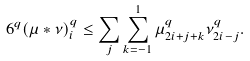Convert formula to latex. <formula><loc_0><loc_0><loc_500><loc_500>6 ^ { q } ( \mu \ast \nu ) _ { i } ^ { q } \leq \sum _ { j } \sum _ { k = - 1 } ^ { 1 } \mu _ { 2 i + j + k } ^ { q } \nu _ { 2 i - j } ^ { q } .</formula> 